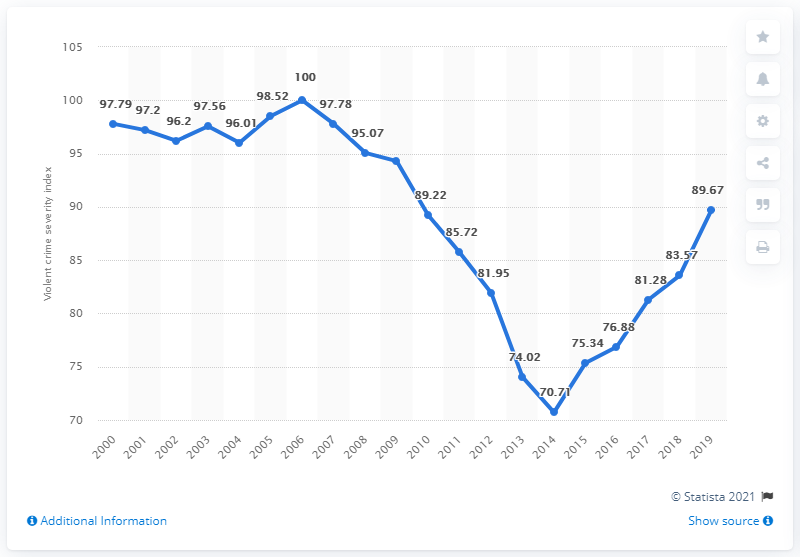Give some essential details in this illustration. The sum of 2018 and 2019 is 173.24. The year with the least index is 2014. In 2000, the Violent Crime Severity Index was 97.79. In 2019, the Violent Crime Severity Index in Canada was 89.67, representing a slight decrease from the previous year. 